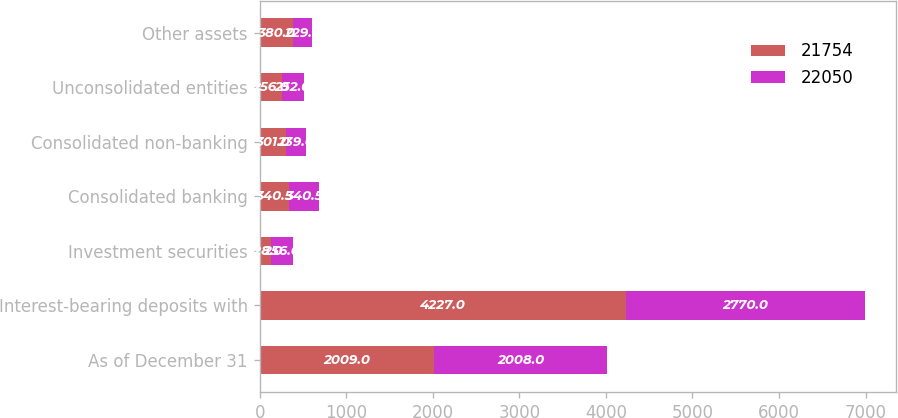Convert chart. <chart><loc_0><loc_0><loc_500><loc_500><stacked_bar_chart><ecel><fcel>As of December 31<fcel>Interest-bearing deposits with<fcel>Investment securities<fcel>Consolidated banking<fcel>Consolidated non-banking<fcel>Unconsolidated entities<fcel>Other assets<nl><fcel>21754<fcel>2009<fcel>4227<fcel>128<fcel>340.5<fcel>301<fcel>256<fcel>380<nl><fcel>22050<fcel>2008<fcel>2770<fcel>256<fcel>340.5<fcel>239<fcel>252<fcel>229<nl></chart> 